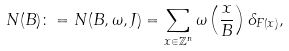Convert formula to latex. <formula><loc_0><loc_0><loc_500><loc_500>N ( B ) \colon = N ( B , \omega , J ) = \sum _ { x \in \mathbb { Z } ^ { n } } \omega \left ( \frac { x } { B } \right ) \delta _ { F ( x ) } ,</formula> 